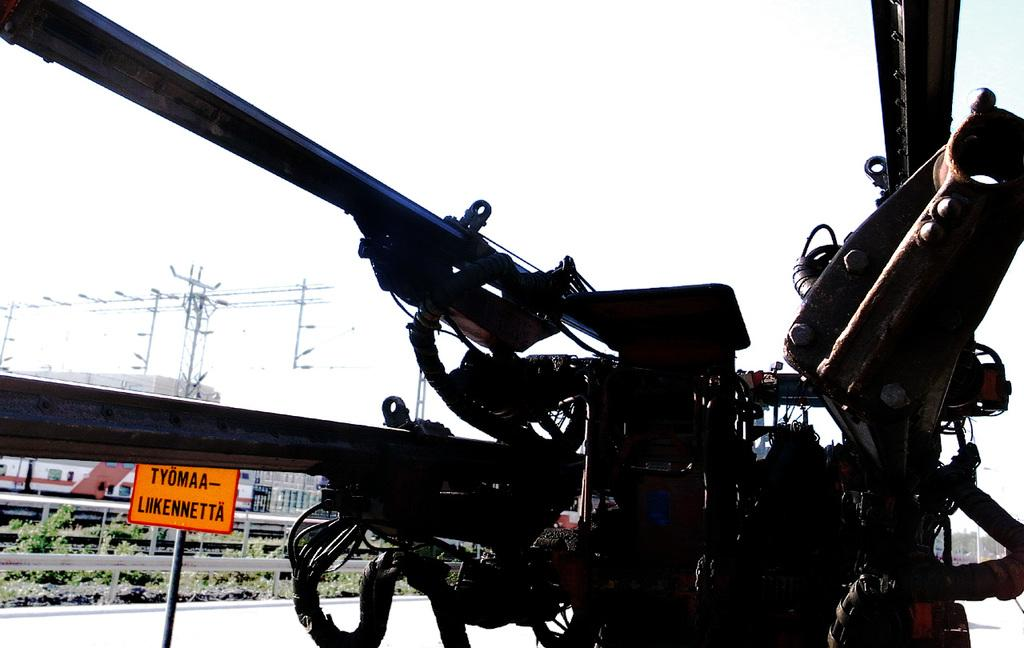What is the main object in the image? There is a machine in the image. What can be seen in the background of the image? Electric poles, electric cables, barriers, plants, and the sky are visible in the background of the image. What type of mint is growing on the machine in the image? There is no mint present in the image, and the machine does not have any plants growing on it. 